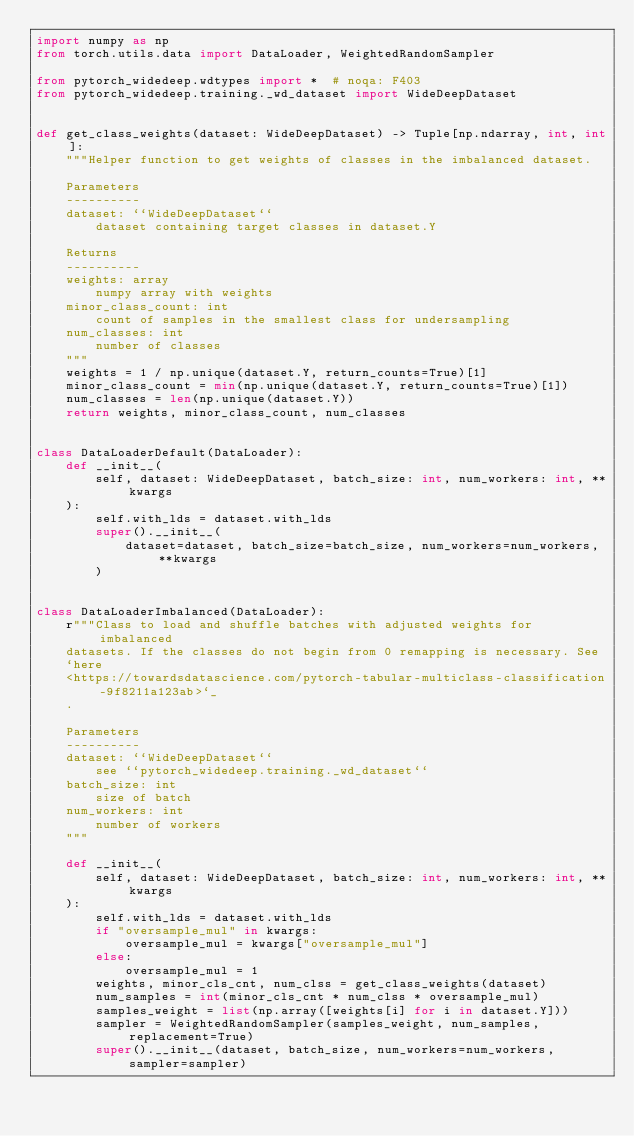Convert code to text. <code><loc_0><loc_0><loc_500><loc_500><_Python_>import numpy as np
from torch.utils.data import DataLoader, WeightedRandomSampler

from pytorch_widedeep.wdtypes import *  # noqa: F403
from pytorch_widedeep.training._wd_dataset import WideDeepDataset


def get_class_weights(dataset: WideDeepDataset) -> Tuple[np.ndarray, int, int]:
    """Helper function to get weights of classes in the imbalanced dataset.

    Parameters
    ----------
    dataset: ``WideDeepDataset``
        dataset containing target classes in dataset.Y

    Returns
    ----------
    weights: array
        numpy array with weights
    minor_class_count: int
        count of samples in the smallest class for undersampling
    num_classes: int
        number of classes
    """
    weights = 1 / np.unique(dataset.Y, return_counts=True)[1]
    minor_class_count = min(np.unique(dataset.Y, return_counts=True)[1])
    num_classes = len(np.unique(dataset.Y))
    return weights, minor_class_count, num_classes


class DataLoaderDefault(DataLoader):
    def __init__(
        self, dataset: WideDeepDataset, batch_size: int, num_workers: int, **kwargs
    ):
        self.with_lds = dataset.with_lds
        super().__init__(
            dataset=dataset, batch_size=batch_size, num_workers=num_workers, **kwargs
        )


class DataLoaderImbalanced(DataLoader):
    r"""Class to load and shuffle batches with adjusted weights for imbalanced
    datasets. If the classes do not begin from 0 remapping is necessary. See
    `here
    <https://towardsdatascience.com/pytorch-tabular-multiclass-classification-9f8211a123ab>`_
    .

    Parameters
    ----------
    dataset: ``WideDeepDataset``
        see ``pytorch_widedeep.training._wd_dataset``
    batch_size: int
        size of batch
    num_workers: int
        number of workers
    """

    def __init__(
        self, dataset: WideDeepDataset, batch_size: int, num_workers: int, **kwargs
    ):
        self.with_lds = dataset.with_lds
        if "oversample_mul" in kwargs:
            oversample_mul = kwargs["oversample_mul"]
        else:
            oversample_mul = 1
        weights, minor_cls_cnt, num_clss = get_class_weights(dataset)
        num_samples = int(minor_cls_cnt * num_clss * oversample_mul)
        samples_weight = list(np.array([weights[i] for i in dataset.Y]))
        sampler = WeightedRandomSampler(samples_weight, num_samples, replacement=True)
        super().__init__(dataset, batch_size, num_workers=num_workers, sampler=sampler)
</code> 